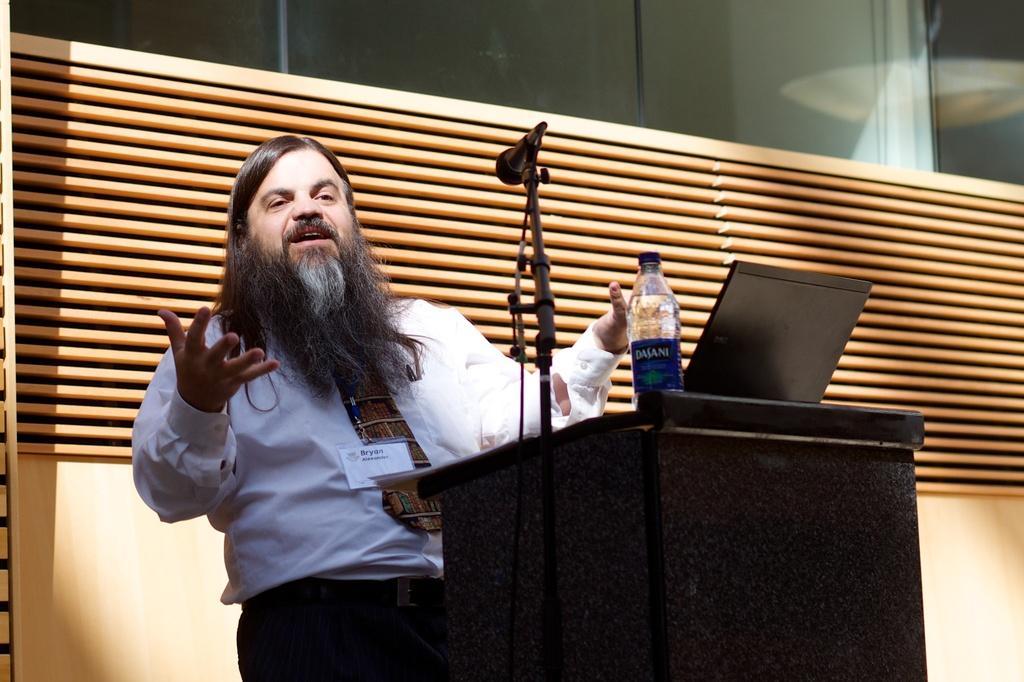Can you describe this image briefly? This image is taken indoors. In the background there is a wall and there is a blind. In the middle of the image there is a podium with a laptop, a bottle and a mic on it. A man is standing and he is talking. 